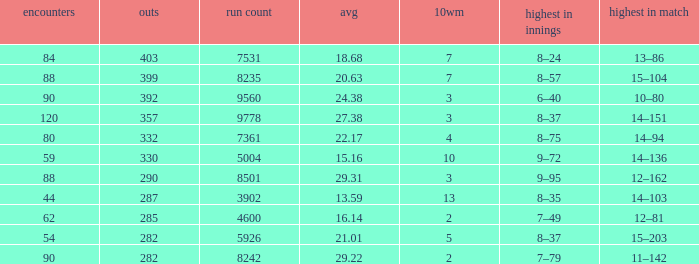What is the total number of wickets that have runs under 4600 and matches under 44? None. 